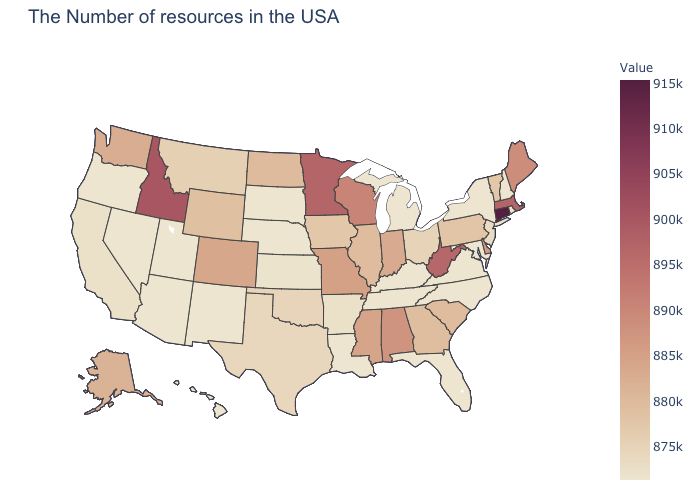Among the states that border South Dakota , does Wyoming have the highest value?
Be succinct. No. Does Arkansas have the highest value in the USA?
Concise answer only. No. 